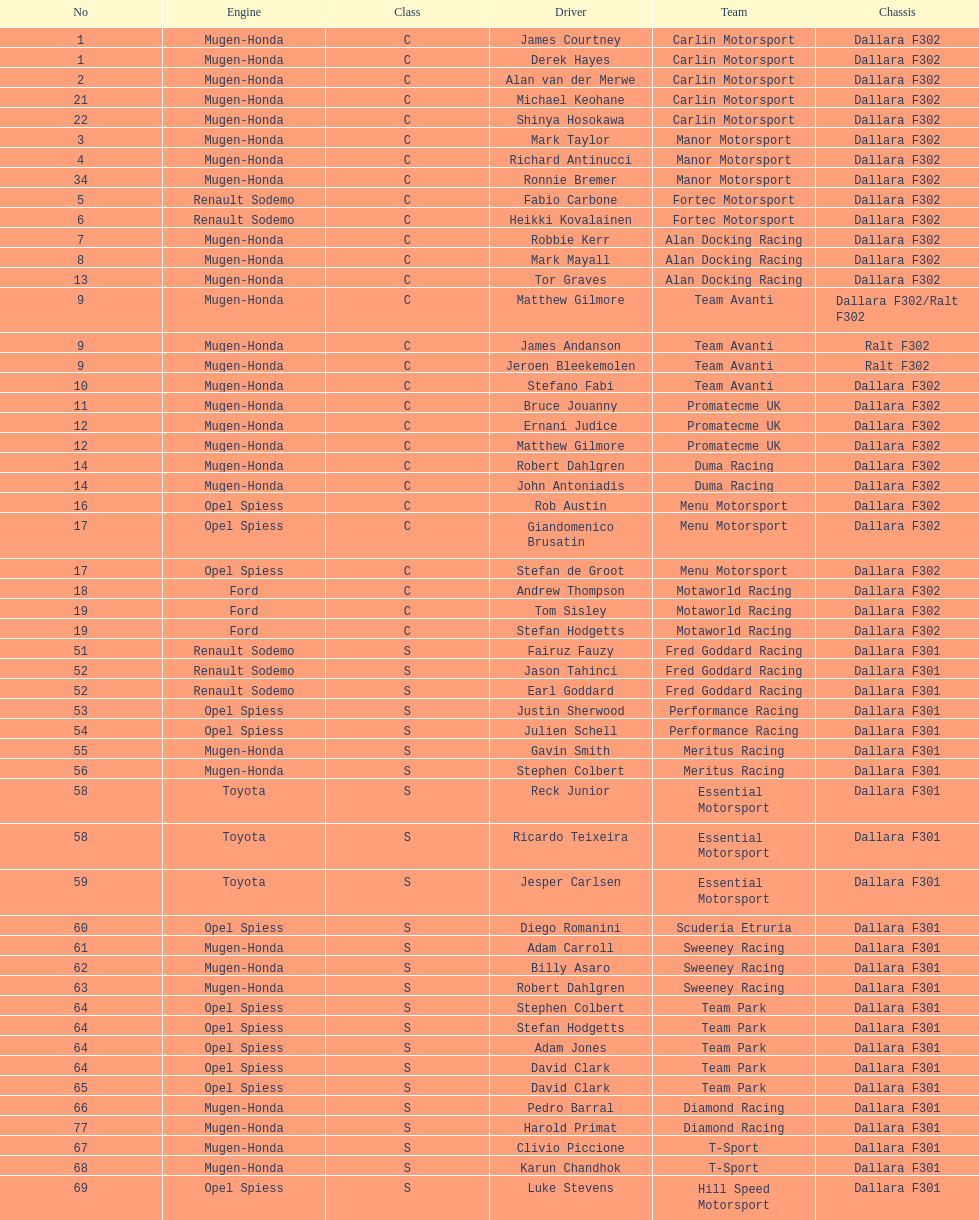The two drivers on t-sport are clivio piccione and what other driver? Karun Chandhok. 